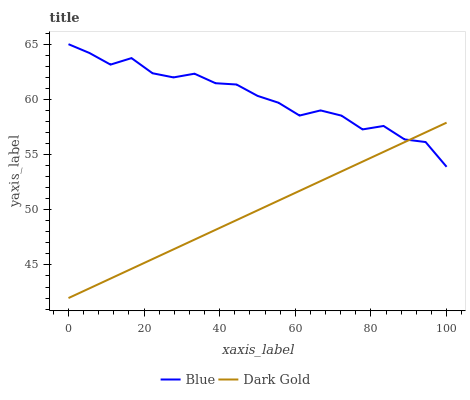Does Dark Gold have the minimum area under the curve?
Answer yes or no. Yes. Does Blue have the maximum area under the curve?
Answer yes or no. Yes. Does Dark Gold have the maximum area under the curve?
Answer yes or no. No. Is Dark Gold the smoothest?
Answer yes or no. Yes. Is Blue the roughest?
Answer yes or no. Yes. Is Dark Gold the roughest?
Answer yes or no. No. Does Dark Gold have the lowest value?
Answer yes or no. Yes. Does Blue have the highest value?
Answer yes or no. Yes. Does Dark Gold have the highest value?
Answer yes or no. No. Does Dark Gold intersect Blue?
Answer yes or no. Yes. Is Dark Gold less than Blue?
Answer yes or no. No. Is Dark Gold greater than Blue?
Answer yes or no. No. 